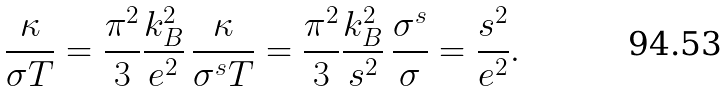<formula> <loc_0><loc_0><loc_500><loc_500>\frac { \kappa } { \sigma T } = \frac { \pi ^ { 2 } } { 3 } \frac { k _ { B } ^ { 2 } } { e ^ { 2 } } \, \frac { \kappa } { \sigma ^ { s } T } = \frac { \pi ^ { 2 } } { 3 } \frac { k _ { B } ^ { 2 } } { s ^ { 2 } } \, \frac { \sigma ^ { s } } { \sigma } = \frac { s ^ { 2 } } { e ^ { 2 } } .</formula> 